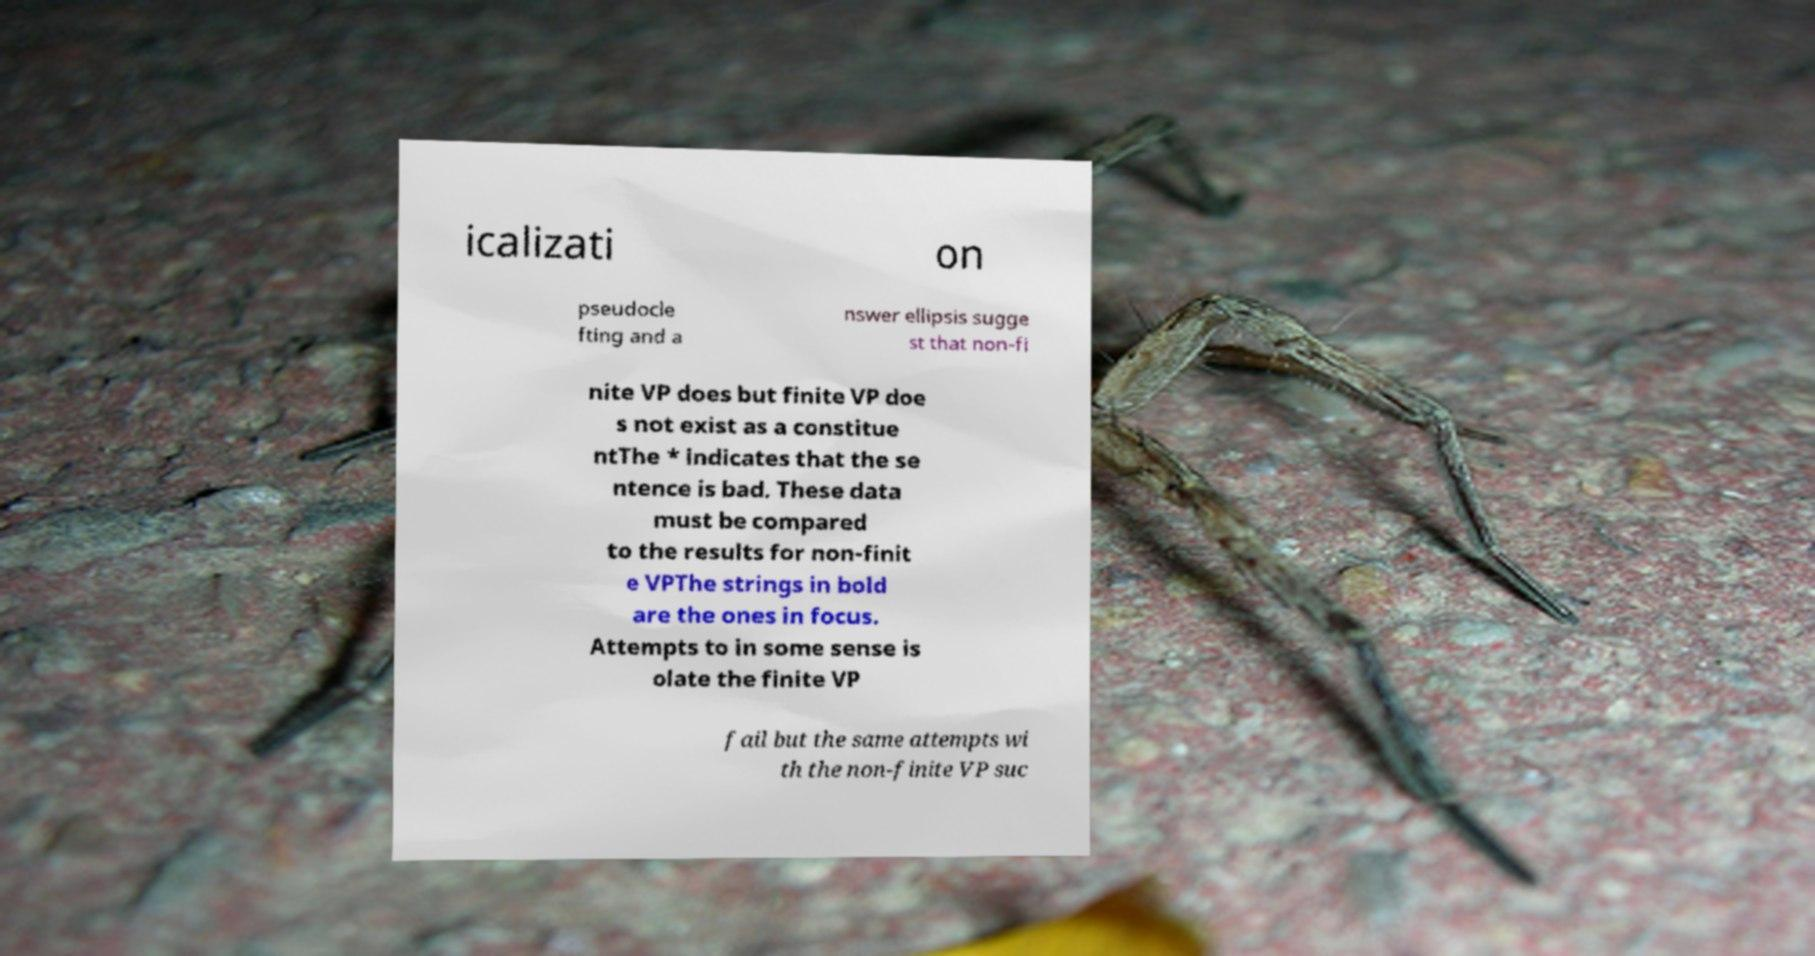Please read and relay the text visible in this image. What does it say? icalizati on pseudocle fting and a nswer ellipsis sugge st that non-fi nite VP does but finite VP doe s not exist as a constitue ntThe * indicates that the se ntence is bad. These data must be compared to the results for non-finit e VPThe strings in bold are the ones in focus. Attempts to in some sense is olate the finite VP fail but the same attempts wi th the non-finite VP suc 